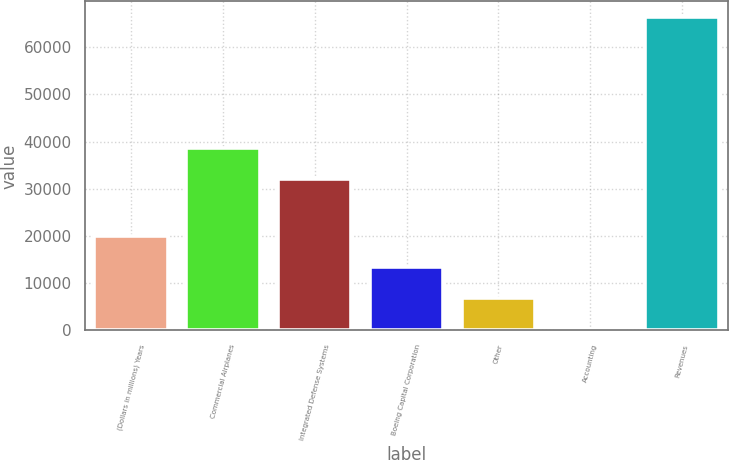Convert chart to OTSL. <chart><loc_0><loc_0><loc_500><loc_500><bar_chart><fcel>(Dollars in millions) Years<fcel>Commercial Airplanes<fcel>Integrated Defense Systems<fcel>Boeing Capital Corporation<fcel>Other<fcel>Accounting<fcel>Revenues<nl><fcel>20037.9<fcel>38701.3<fcel>32080<fcel>13416.6<fcel>6795.3<fcel>174<fcel>66387<nl></chart> 